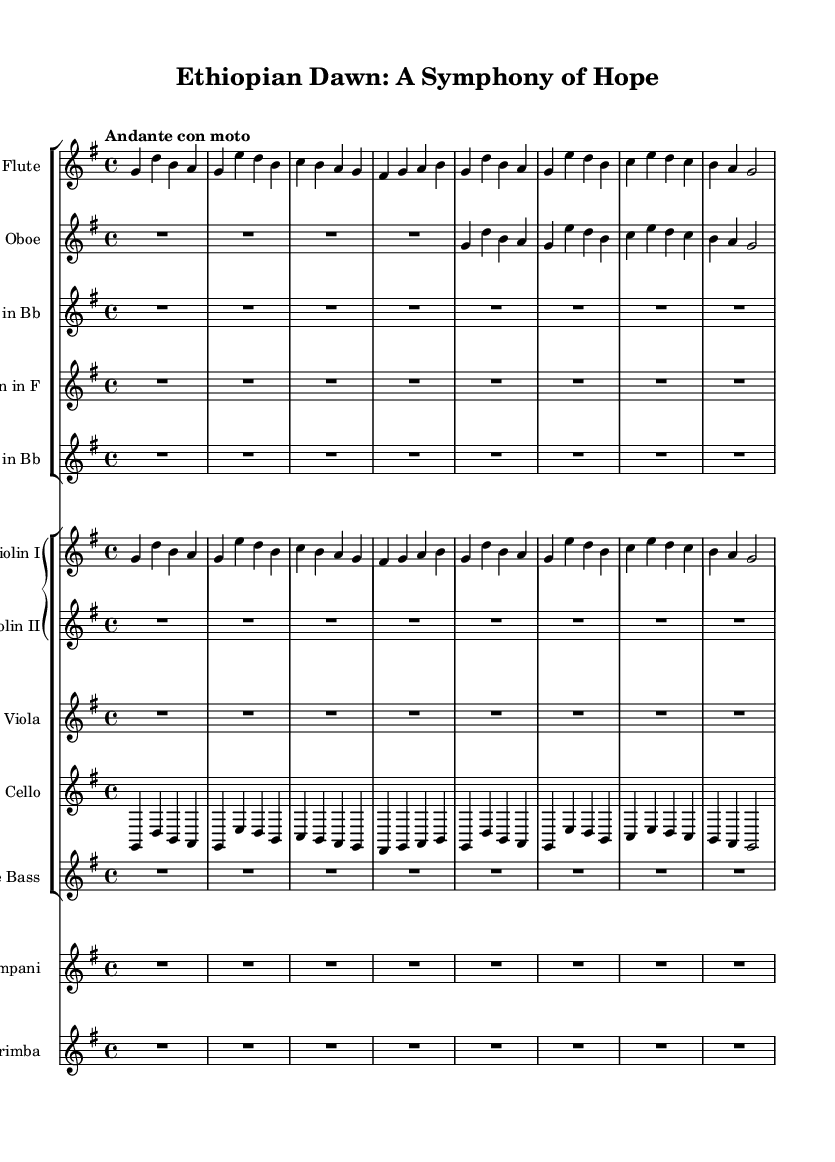What is the key signature of this symphony? The key signature is G major, which has one sharp (F#) indicated at the beginning of the staff.
Answer: G major What is the time signature of this piece? The time signature shows a "4/4" notation, indicating that there are four beats per measure.
Answer: 4/4 What is the tempo marking for this symphony? The tempo marking indicates "Andante con moto," suggesting a moderately slow tempo with some motion.
Answer: Andante con moto How many instruments are featured in this score? By counting the instruments listed in the score, there are a total of 13 distinct parts, including strings and winds.
Answer: 13 Which instrument has the first entrance in the piece? The flute is the first instrument to have notated pitches, appearing right at the beginning of the score.
Answer: Flute What section plays the melody during the first part of the score? The violin I part carries the primary melody at the beginning, indicated by the note sequences in that staff.
Answer: Violin I Which instruments have rests at the beginning of the piece? Multiple instruments including oboe, clarinet, horn, trumpet, and double bass have rests marked to start the performance.
Answer: Oboe, clarinet, horn, trumpet, double bass 